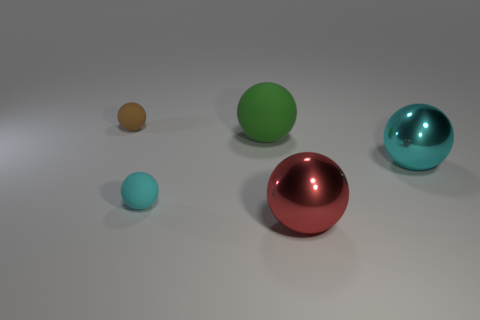There is a cyan shiny object to the right of the tiny cyan rubber sphere; is it the same shape as the tiny brown rubber thing?
Make the answer very short. Yes. Is there anything else that has the same size as the brown rubber ball?
Give a very brief answer. Yes. Are there fewer cyan metallic balls that are on the left side of the big rubber sphere than red metallic objects that are behind the tiny brown rubber object?
Your answer should be compact. No. How many other objects are there of the same shape as the red thing?
Your answer should be very brief. 4. What is the size of the cyan sphere right of the shiny ball that is in front of the small matte sphere that is in front of the cyan metal thing?
Offer a very short reply. Large. What number of green things are big matte spheres or shiny cubes?
Your response must be concise. 1. There is a object that is behind the green rubber sphere; is it the same size as the cyan matte object on the right side of the brown rubber thing?
Your response must be concise. Yes. Is there a green ball that has the same material as the small cyan sphere?
Offer a terse response. Yes. Is there a metal thing in front of the large metallic sphere that is behind the cyan sphere left of the large rubber sphere?
Ensure brevity in your answer.  Yes. Are there any large matte balls left of the green ball?
Provide a succinct answer. No. 